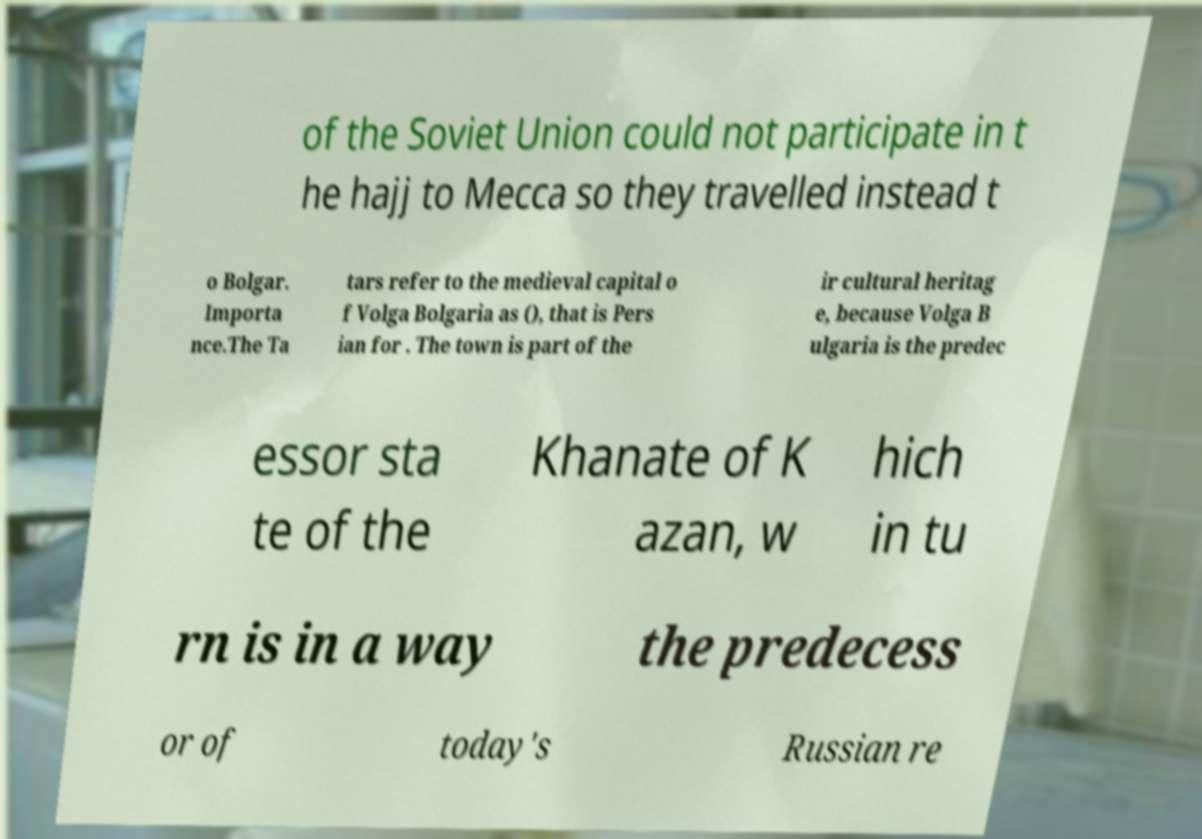There's text embedded in this image that I need extracted. Can you transcribe it verbatim? of the Soviet Union could not participate in t he hajj to Mecca so they travelled instead t o Bolgar. Importa nce.The Ta tars refer to the medieval capital o f Volga Bolgaria as (), that is Pers ian for . The town is part of the ir cultural heritag e, because Volga B ulgaria is the predec essor sta te of the Khanate of K azan, w hich in tu rn is in a way the predecess or of today's Russian re 